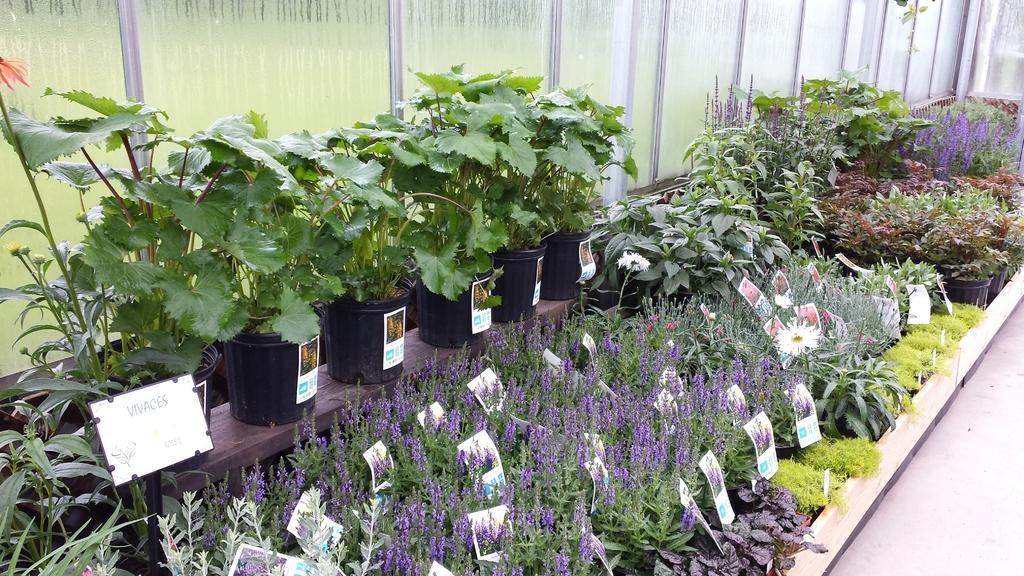In one or two sentences, can you explain what this image depicts? In the image we can see the nursery and here we can see the stickers and the board. Here we can see glass wall and the floor. 